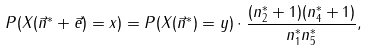Convert formula to latex. <formula><loc_0><loc_0><loc_500><loc_500>P ( X ( \vec { n } ^ { * } + \vec { e } ) = x ) = P ( X ( \vec { n } ^ { * } ) = y ) \cdot \frac { ( n _ { 2 } ^ { * } + 1 ) ( n _ { 4 } ^ { * } + 1 ) } { n _ { 1 } ^ { * } n _ { 5 } ^ { * } } ,</formula> 